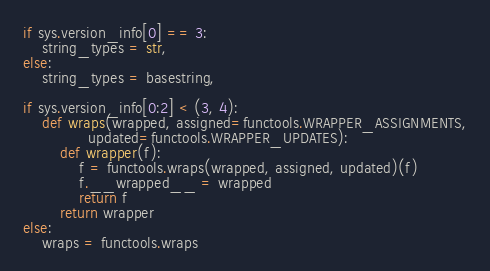Convert code to text. <code><loc_0><loc_0><loc_500><loc_500><_Python_>

if sys.version_info[0] == 3:
    string_types = str,
else:
    string_types = basestring,

if sys.version_info[0:2] < (3, 4):
    def wraps(wrapped, assigned=functools.WRAPPER_ASSIGNMENTS,
              updated=functools.WRAPPER_UPDATES):
        def wrapper(f):
            f = functools.wraps(wrapped, assigned, updated)(f)
            f.__wrapped__ = wrapped
            return f
        return wrapper
else:
    wraps = functools.wraps
</code> 